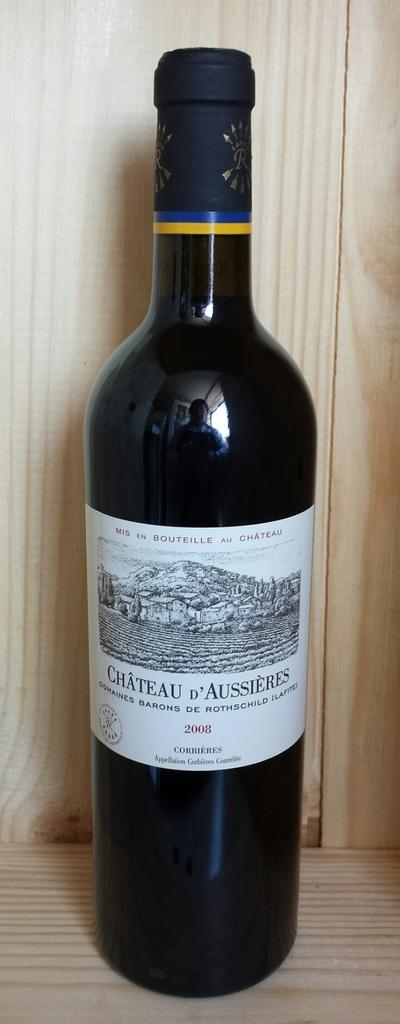<image>
Give a short and clear explanation of the subsequent image. Bottle of 2008 Chateau D'Aussieres Baron de Rothchild wine 